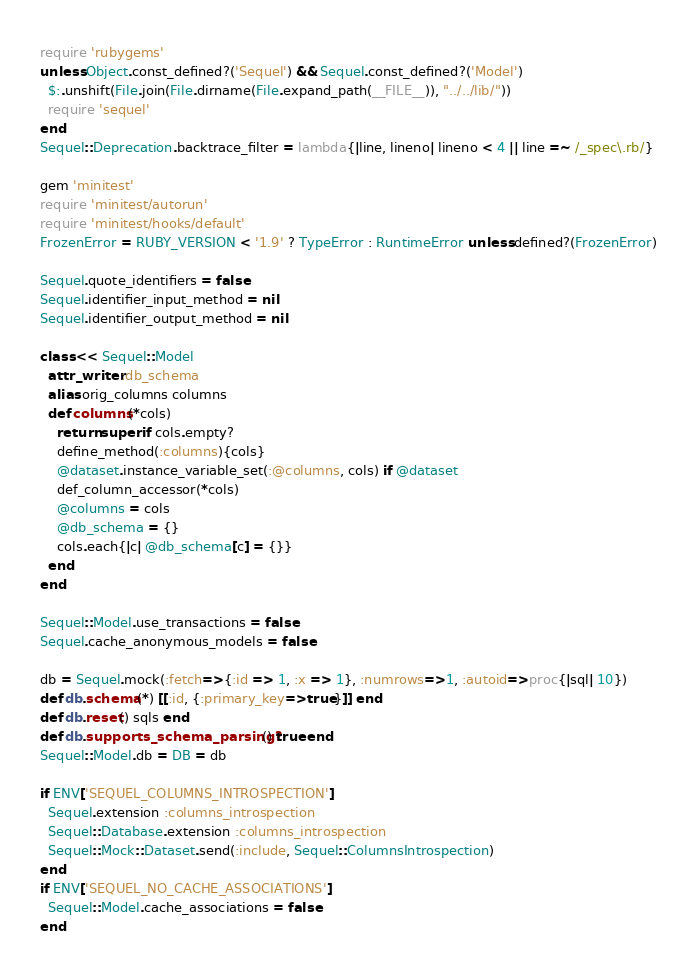Convert code to text. <code><loc_0><loc_0><loc_500><loc_500><_Ruby_>require 'rubygems'
unless Object.const_defined?('Sequel') && Sequel.const_defined?('Model') 
  $:.unshift(File.join(File.dirname(File.expand_path(__FILE__)), "../../lib/"))
  require 'sequel'
end
Sequel::Deprecation.backtrace_filter = lambda{|line, lineno| lineno < 4 || line =~ /_spec\.rb/}

gem 'minitest'
require 'minitest/autorun'
require 'minitest/hooks/default'
FrozenError = RUBY_VERSION < '1.9' ? TypeError : RuntimeError unless defined?(FrozenError)

Sequel.quote_identifiers = false
Sequel.identifier_input_method = nil
Sequel.identifier_output_method = nil

class << Sequel::Model
  attr_writer :db_schema
  alias orig_columns columns
  def columns(*cols)
    return super if cols.empty?
    define_method(:columns){cols}
    @dataset.instance_variable_set(:@columns, cols) if @dataset
    def_column_accessor(*cols)
    @columns = cols
    @db_schema = {}
    cols.each{|c| @db_schema[c] = {}}
  end
end

Sequel::Model.use_transactions = false
Sequel.cache_anonymous_models = false

db = Sequel.mock(:fetch=>{:id => 1, :x => 1}, :numrows=>1, :autoid=>proc{|sql| 10})
def db.schema(*) [[:id, {:primary_key=>true}]] end
def db.reset() sqls end
def db.supports_schema_parsing?() true end
Sequel::Model.db = DB = db

if ENV['SEQUEL_COLUMNS_INTROSPECTION']
  Sequel.extension :columns_introspection
  Sequel::Database.extension :columns_introspection
  Sequel::Mock::Dataset.send(:include, Sequel::ColumnsIntrospection)
end
if ENV['SEQUEL_NO_CACHE_ASSOCIATIONS']
  Sequel::Model.cache_associations = false
end
</code> 